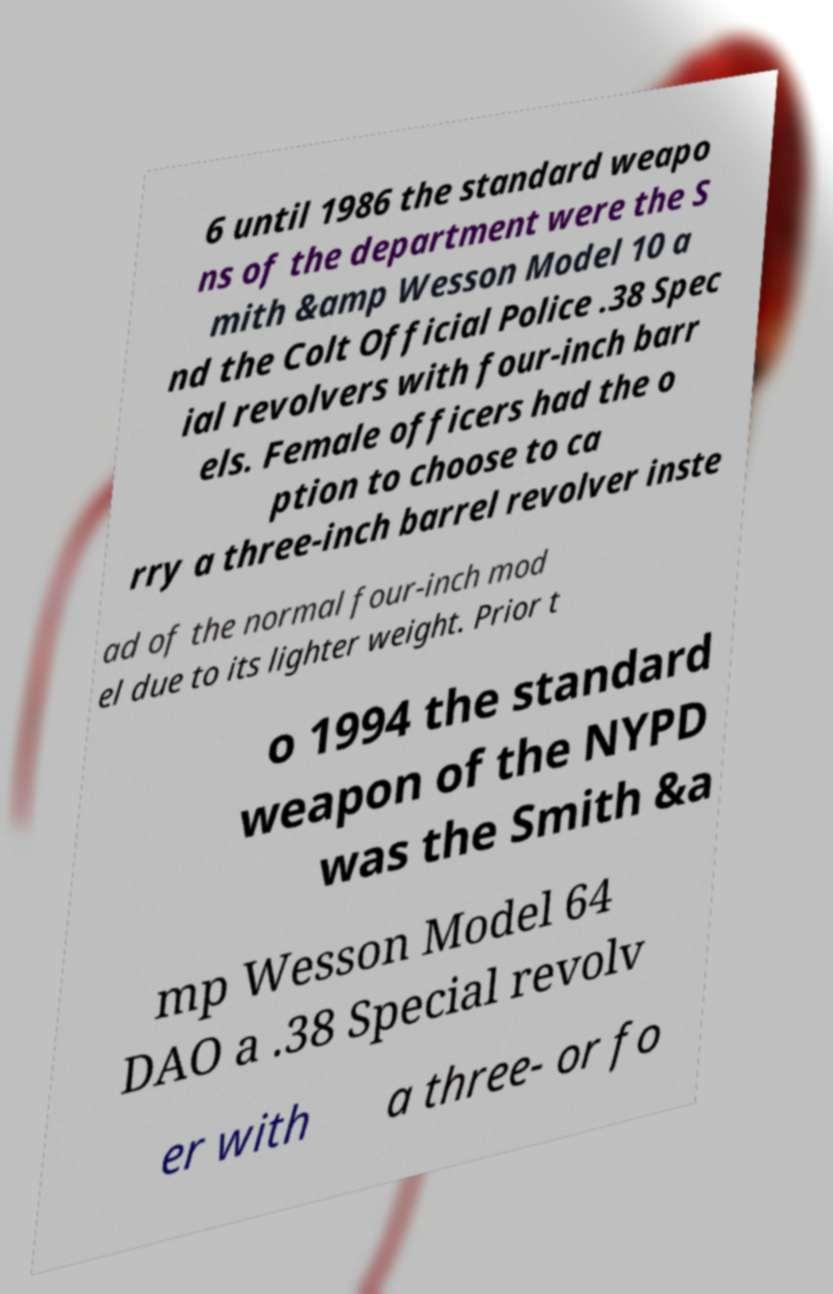What messages or text are displayed in this image? I need them in a readable, typed format. 6 until 1986 the standard weapo ns of the department were the S mith &amp Wesson Model 10 a nd the Colt Official Police .38 Spec ial revolvers with four-inch barr els. Female officers had the o ption to choose to ca rry a three-inch barrel revolver inste ad of the normal four-inch mod el due to its lighter weight. Prior t o 1994 the standard weapon of the NYPD was the Smith &a mp Wesson Model 64 DAO a .38 Special revolv er with a three- or fo 